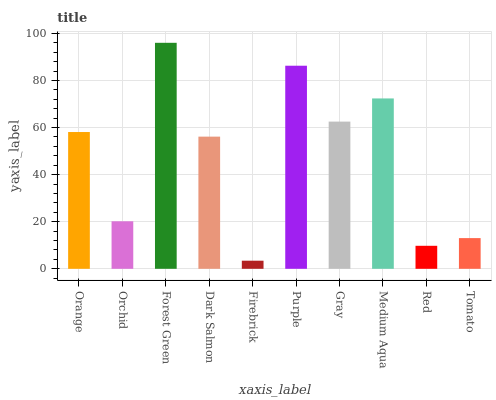Is Firebrick the minimum?
Answer yes or no. Yes. Is Forest Green the maximum?
Answer yes or no. Yes. Is Orchid the minimum?
Answer yes or no. No. Is Orchid the maximum?
Answer yes or no. No. Is Orange greater than Orchid?
Answer yes or no. Yes. Is Orchid less than Orange?
Answer yes or no. Yes. Is Orchid greater than Orange?
Answer yes or no. No. Is Orange less than Orchid?
Answer yes or no. No. Is Orange the high median?
Answer yes or no. Yes. Is Dark Salmon the low median?
Answer yes or no. Yes. Is Red the high median?
Answer yes or no. No. Is Medium Aqua the low median?
Answer yes or no. No. 